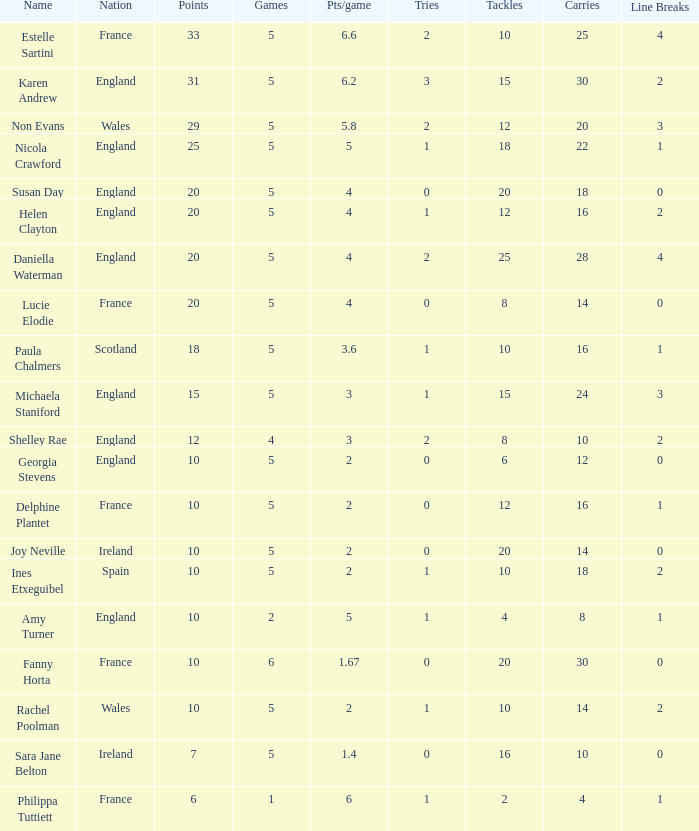Can you tell me the lowest Pts/game that has the Name of philippa tuttiett, and the Points larger then 6? None. 